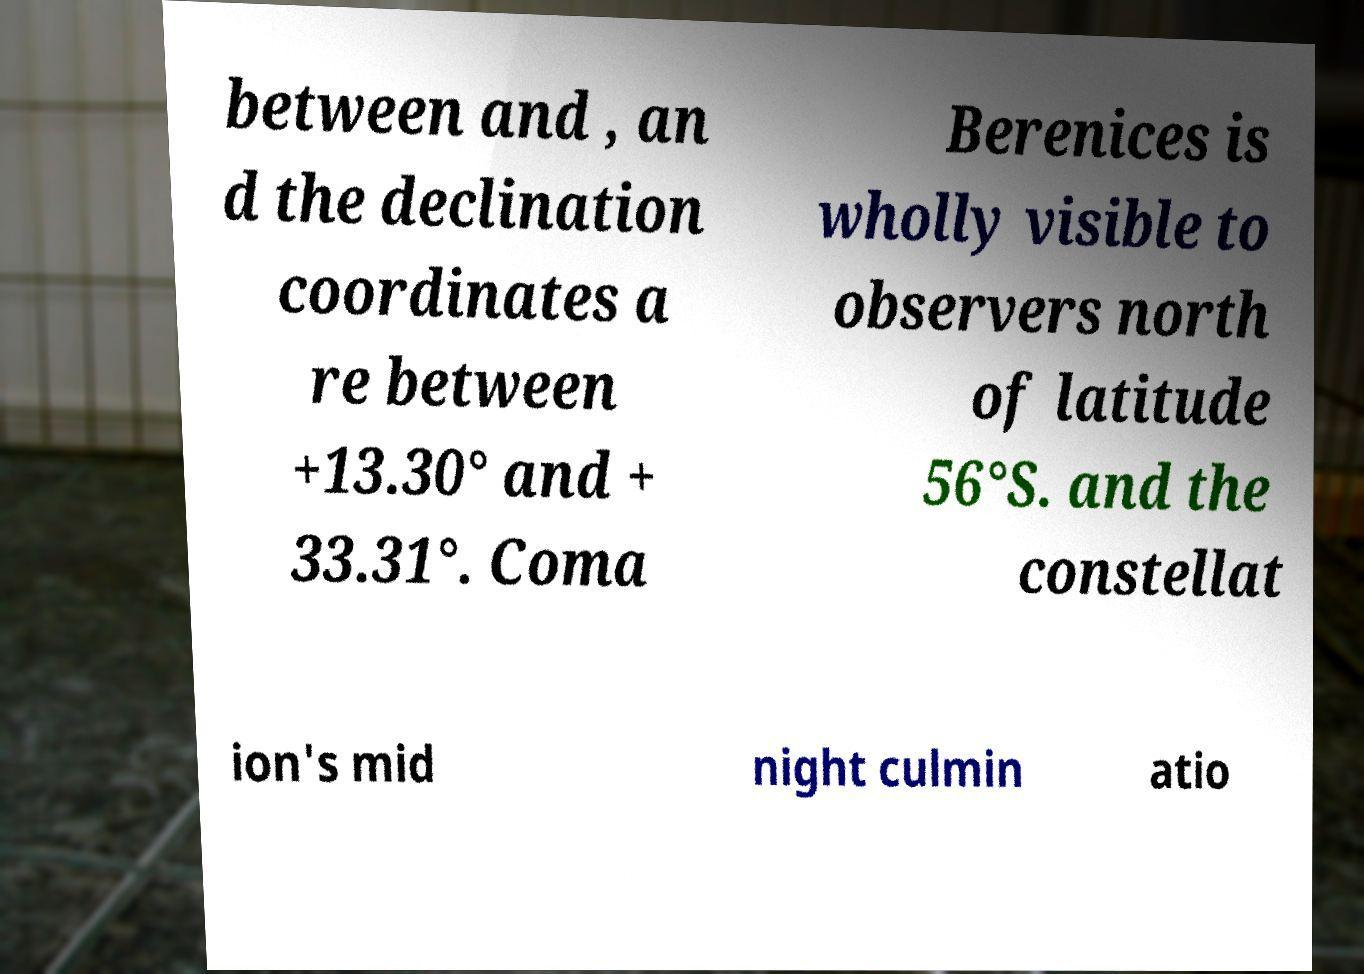Can you read and provide the text displayed in the image?This photo seems to have some interesting text. Can you extract and type it out for me? between and , an d the declination coordinates a re between +13.30° and + 33.31°. Coma Berenices is wholly visible to observers north of latitude 56°S. and the constellat ion's mid night culmin atio 